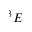Convert formula to latex. <formula><loc_0><loc_0><loc_500><loc_500>^ { 3 } E</formula> 